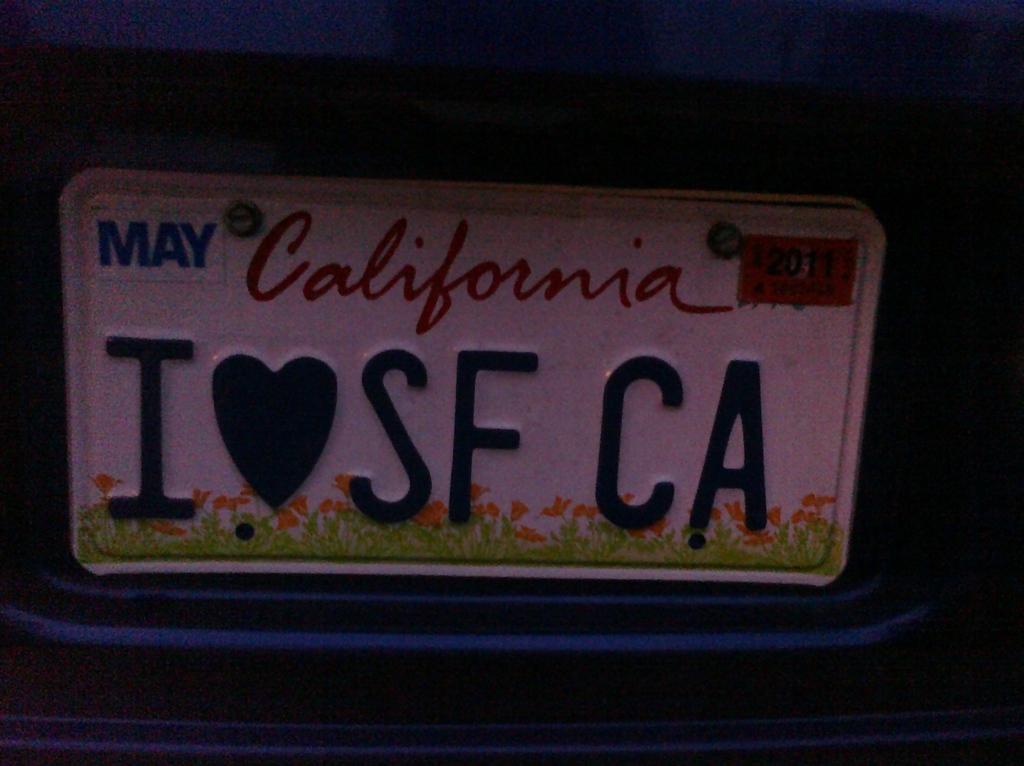How would you summarize this image in a sentence or two? In the picture I can see a board on which there is something written on it. The background of the image is dark. 